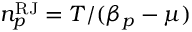<formula> <loc_0><loc_0><loc_500><loc_500>n _ { p } ^ { R J } = T / ( \beta _ { p } - \mu )</formula> 